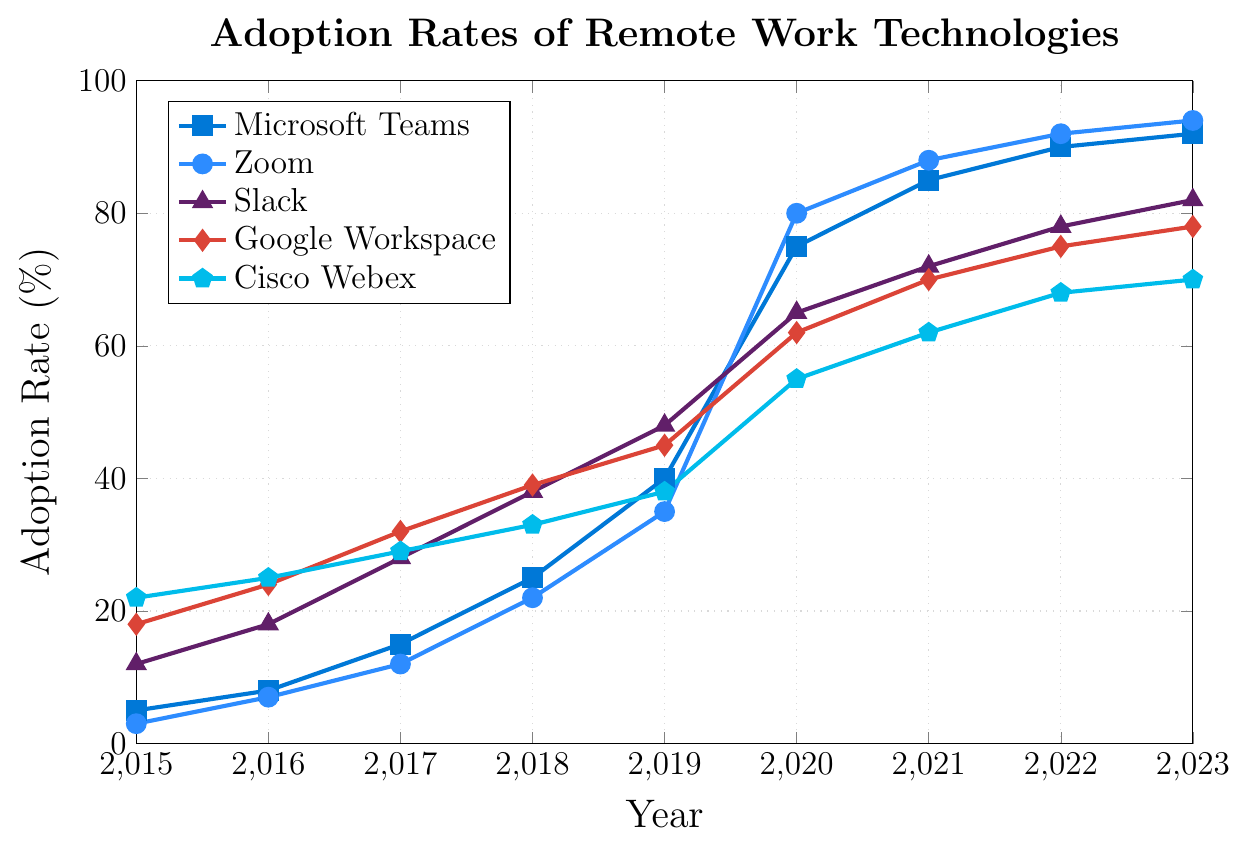Which remote work technology had the highest adoption rate in 2015? According to the plot, in 2015, Cisco Webex had the highest adoption rate with a value of 22%.
Answer: Cisco Webex How did the adoption rate of Zoom change from 2019 to 2020? The adoption rate of Zoom increased from 35% in 2019 to 80% in 2020. The change can be calculated as 80% - 35% = 45%.
Answer: Increased by 45% Which technology saw the largest increase in adoption rate between 2015 and 2023? By examining the endpoints of each line, we see that Microsoft Teams increased from 5% in 2015 to 92% in 2023, resulting in an increase of 87%. This is the largest increase among all the listed technologies.
Answer: Microsoft Teams In what year did Google Workspace surpass a 50% adoption rate? According to the plot, Google Workspace surpassed a 50% adoption rate in 2020, reaching 62%.
Answer: 2020 Compare the adoption rate of Slack in 2017 and 2023. What is the difference? Slack had an adoption rate of 28% in 2017 and 82% in 2023. The difference is 82% - 28% = 54%.
Answer: 54% Which technology experienced the steadiest growth from 2015 to 2023? Google Workspace shows the most consistent growth with a relatively smooth increase in adoption rate over the years, without sharp spikes or drops.
Answer: Google Workspace What is the adoption rate of Microsoft Teams in 2021? According to the plot, the adoption rate of Microsoft Teams in 2021 is 85%.
Answer: 85% Between Microsoft Teams and Cisco Webex, which had a higher adoption rate in 2019, and by how much? In 2019, Microsoft Teams had an adoption rate of 40%, while Cisco Webex had an adoption rate of 38%. The difference is 40% - 38% = 2%.
Answer: Microsoft Teams by 2% Which technology had the smallest adoption rate change from 2022 to 2023? Examining the plot, Microsoft Teams increased from 90% to 92% (2%), Zoom increased from 92% to 94% (2%), Slack increased from 78% to 82% (4%), Google Workspace increased from 75% to 78% (3%), and Cisco Webex increased from 68% to 70% (2%). Microsoft Teams, Zoom, and Cisco Webex all had the smallest adoption rate change of 2%.
Answer: Microsoft Teams, Zoom, and Cisco Webex What was the trend of adoption rates for all technologies from 2019 to 2020, and which technology saw the steepest increase? All technologies showed a sharp increase in adoption rates from 2019 to 2020. Zoom saw the steepest increase, from 35% to 80%, which is a change of 45%.
Answer: Zoom 